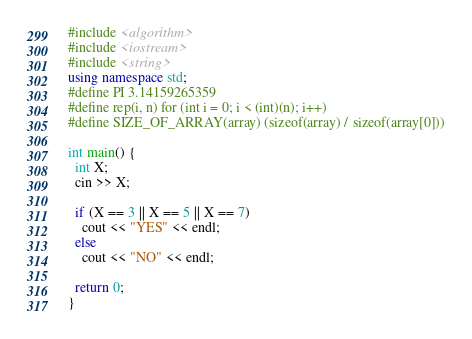Convert code to text. <code><loc_0><loc_0><loc_500><loc_500><_C++_>#include <algorithm>
#include <iostream>
#include <string>
using namespace std;
#define PI 3.14159265359
#define rep(i, n) for (int i = 0; i < (int)(n); i++)
#define SIZE_OF_ARRAY(array) (sizeof(array) / sizeof(array[0]))

int main() {
  int X;
  cin >> X;

  if (X == 3 || X == 5 || X == 7)
    cout << "YES" << endl;
  else
    cout << "NO" << endl;

  return 0;
}
</code> 